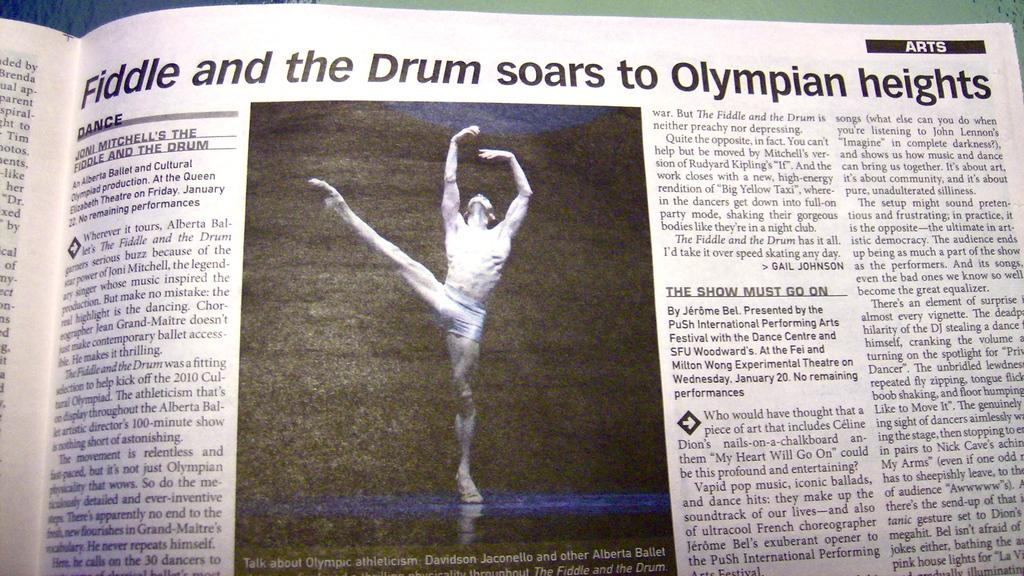<image>
Write a terse but informative summary of the picture. A newspaper article in the arts section with a picture of a male ballet dancer on it. 